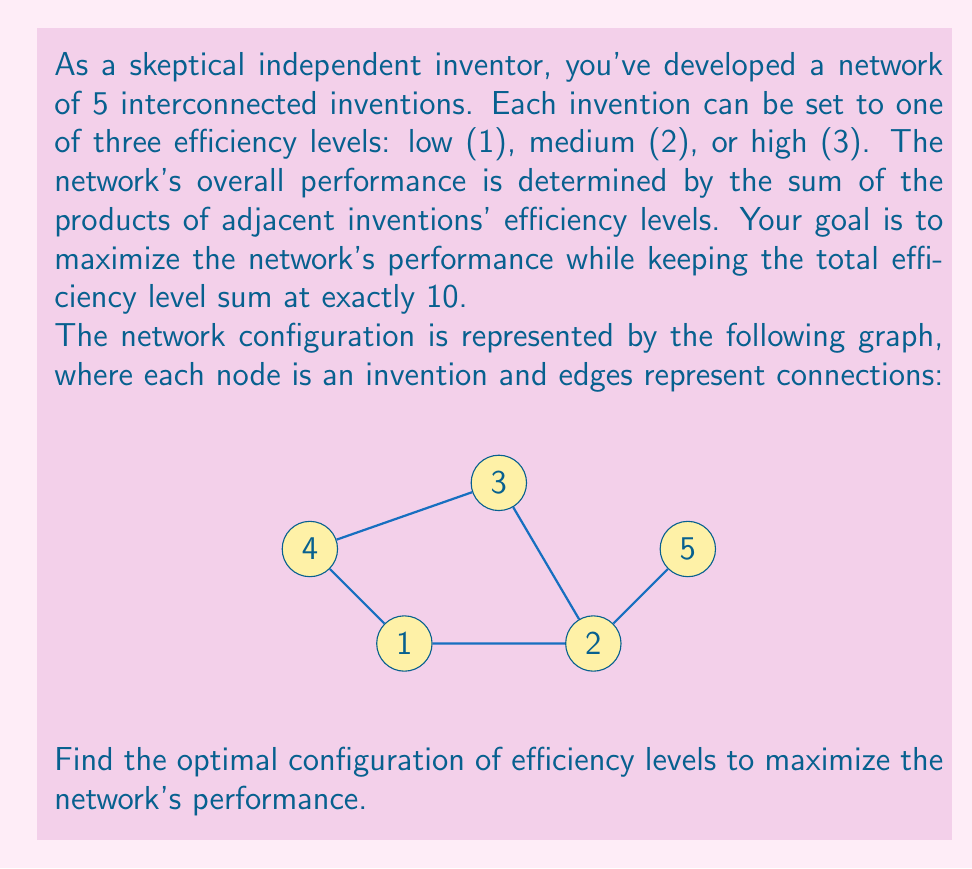Show me your answer to this math problem. Let's approach this step-by-step:

1) Let $x_1, x_2, x_3, x_4, x_5$ represent the efficiency levels of inventions 1, 2, 3, 4, and 5 respectively.

2) The constraint is:
   $$x_1 + x_2 + x_3 + x_4 + x_5 = 10$$

3) The performance to maximize is:
   $$P = x_1x_2 + x_2x_3 + x_3x_4 + x_4x_1 + x_2x_5$$

4) Given the constraint and that each $x_i \in \{1,2,3\}$, we can deduce that at least one invention must be set to 3, and at least two must be set to 1 or 2.

5) Invention 2 has the most connections (3), so it's likely to be optimal to set it to 3.

6) If we set $x_2 = 3$, we need to distribute the remaining 7 points among the other 4 inventions.

7) Inventions 1, 3, and 4 each have two connections, while 5 has only one. It's more efficient to prioritize 1, 3, and 4 over 5.

8) The optimal distribution would be to set two of 1, 3, and 4 to 2, and the other one and 5 to 1.

9) Let's calculate the performance for all such combinations:
   - If $x_1 = x_3 = 2$, $x_4 = x_5 = 1$: $P = 2(3) + 3(2) + 2(1) + 1(2) + 3(1) = 15$
   - If $x_1 = x_4 = 2$, $x_3 = x_5 = 1$: $P = 2(3) + 3(1) + 1(2) + 2(2) + 3(1) = 14$
   - If $x_3 = x_4 = 2$, $x_1 = x_5 = 1$: $P = 1(3) + 3(2) + 2(2) + 2(1) + 3(1) = 14$

10) Therefore, the optimal configuration is $x_1 = 2$, $x_2 = 3$, $x_3 = 2$, $x_4 = 1$, $x_5 = 1$.
Answer: [2, 3, 2, 1, 1] 